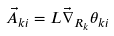Convert formula to latex. <formula><loc_0><loc_0><loc_500><loc_500>\vec { A } _ { k i } = L \vec { \nabla } _ { R _ { k } } \theta _ { k i }</formula> 